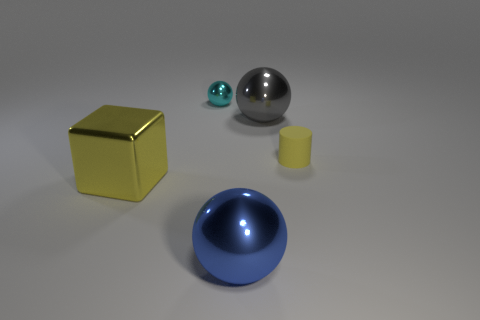Add 5 metal objects. How many objects exist? 10 Subtract all spheres. How many objects are left? 2 Add 4 large yellow cubes. How many large yellow cubes are left? 5 Add 1 spheres. How many spheres exist? 4 Subtract 1 cyan spheres. How many objects are left? 4 Subtract all big blue rubber objects. Subtract all tiny cyan spheres. How many objects are left? 4 